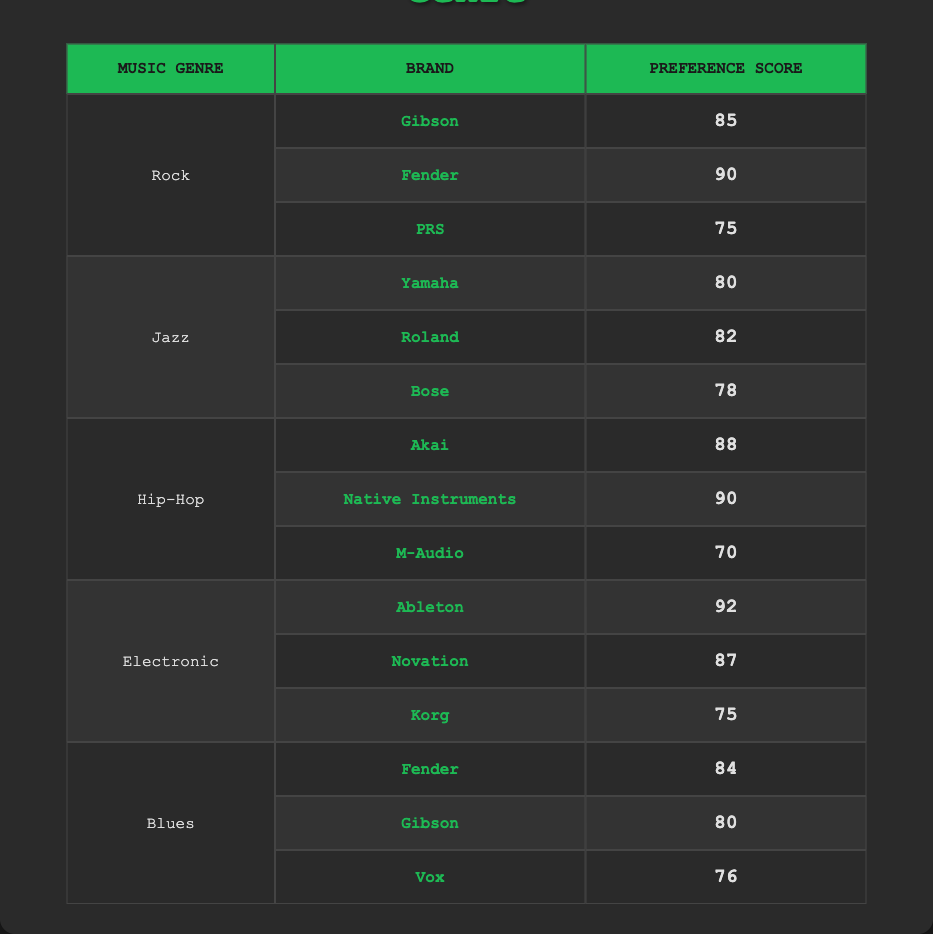What is the highest preference score for brands in the Rock genre? The maximum values for the Rock genre are listed in the rows: Gibson (85), Fender (90), and PRS (75). Fender has the highest preference score among these at 90.
Answer: 90 Which brand has the lowest preference score in the Jazz genre? The brands in the Jazz genre and their scores are Yamaha (80), Roland (82), and Bose (78). By comparing these, Bose has the lowest score of 78.
Answer: Bose What is the average preference score for brands in the Electronic genre? The scores for the Electronic genre are Ableton (92), Novation (87), and Korg (75). Summing these, we get 92 + 87 + 75 = 254. Dividing by 3 gives us an average of 254/3 ≈ 84.67.
Answer: 84.67 Do any brands score exactly 80 in any music genre? From the table, we can check the scores; Gibson in Blues (80) and Yamaha in Jazz (80) match this criteria. Therefore, yes, there are brands with a score of exactly 80.
Answer: Yes Which genre has the highest overall brand preference score from the top brand in each genre? For Rock, the top brand is Fender (90); for Jazz, it's Roland (82); for Hip-Hop, it's Native Instruments (90); for Electronic, it's Ableton (92); and for Blues, it's Fender (84). Among these, Ableton has the highest score of 92, belonging to the Electronic genre.
Answer: Electronic What is the difference in preference score between the highest brand in Hip-Hop and the lowest brand in Jazz? The highest preference score in Hip-Hop is Native Instruments (90), and the lowest in Jazz is Bose (78). The difference can be calculated as 90 - 78 = 12.
Answer: 12 Does the brand Gibson have a preference score of more than 80 in any genre? Gibson scores 85 in Rock and 80 in Blues. Since 85 is greater than 80, Gibson does have at least one score over 80.
Answer: Yes How many total brands are listed in the Blues genre? The Blues genre includes three brands: Fender, Gibson, and Vox. Counting these, there are 3 brands in total for this genre.
Answer: 3 What is the least preferred brand across all genres? Looking at all brands across genres, M-Audio in Hip-Hop has the lowest preference score of 70.
Answer: M-Audio 